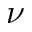<formula> <loc_0><loc_0><loc_500><loc_500>\nu</formula> 